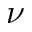<formula> <loc_0><loc_0><loc_500><loc_500>\nu</formula> 